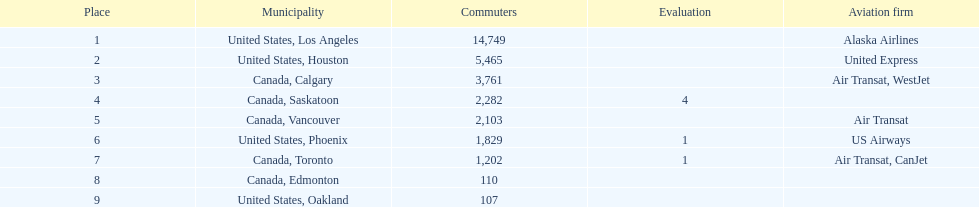How many cities from canada are on this list? 5. 